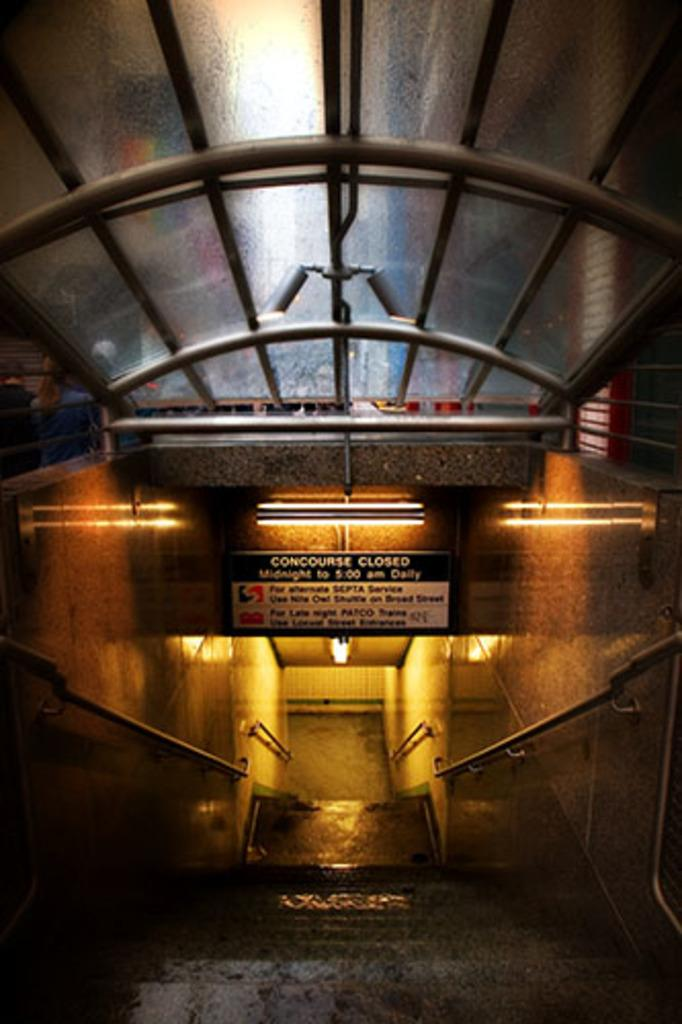What is located in the center of the image? There are fences and a staircase in the center of the image. What can be seen in the background of the image? There is a wall, a roof, lights, a banner, and a few other objects in the background of the image. What type of wax can be seen melting on the staircase in the image? There is no wax present in the image, and therefore no such activity can be observed. 